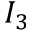Convert formula to latex. <formula><loc_0><loc_0><loc_500><loc_500>I _ { 3 }</formula> 